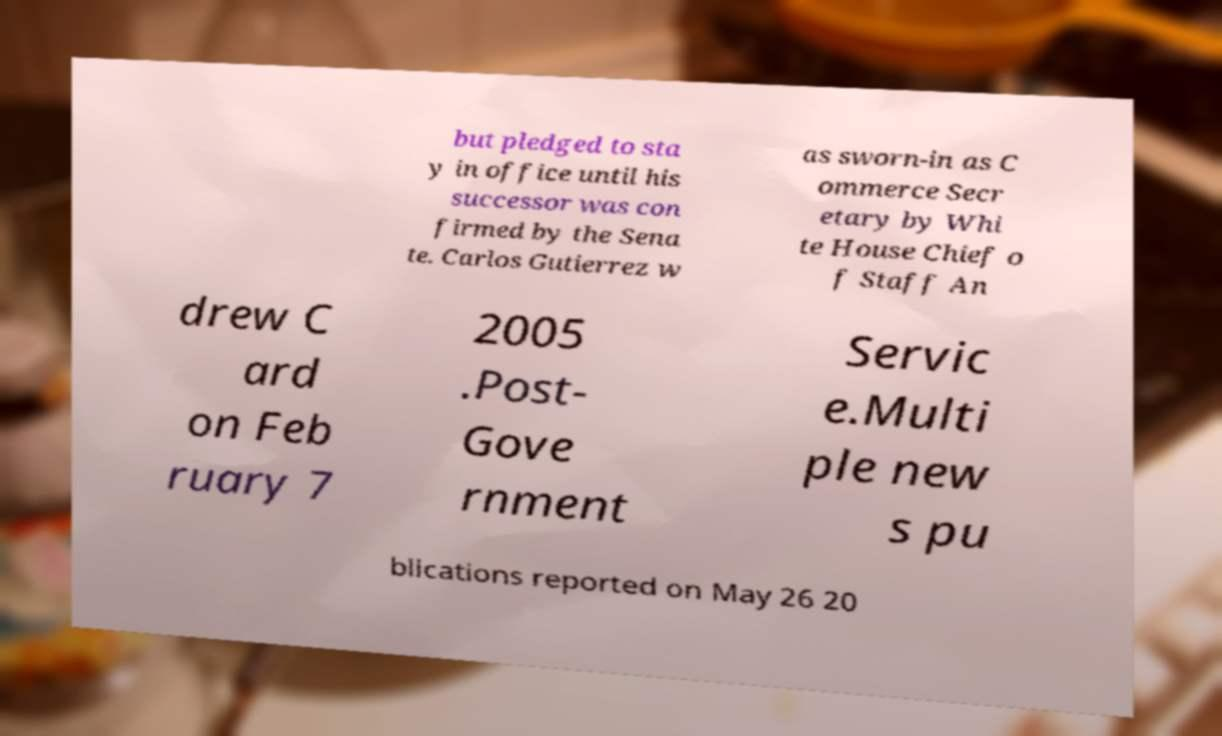What messages or text are displayed in this image? I need them in a readable, typed format. but pledged to sta y in office until his successor was con firmed by the Sena te. Carlos Gutierrez w as sworn-in as C ommerce Secr etary by Whi te House Chief o f Staff An drew C ard on Feb ruary 7 2005 .Post- Gove rnment Servic e.Multi ple new s pu blications reported on May 26 20 